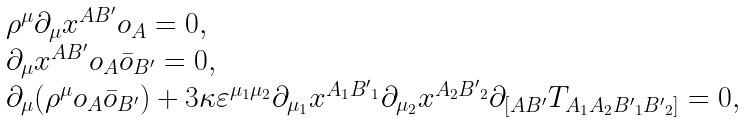Convert formula to latex. <formula><loc_0><loc_0><loc_500><loc_500>\begin{array} { l } \rho ^ { \mu } \partial _ { \mu } x ^ { A B ^ { \prime } } o _ { A } = 0 , \\ \partial _ { \mu } x ^ { A B ^ { \prime } } o _ { A } \bar { o } _ { B ^ { \prime } } = 0 , \\ \partial _ { \mu } ( \rho ^ { \mu } o _ { A } \bar { o } _ { B ^ { \prime } } ) + 3 \kappa \varepsilon ^ { \mu _ { 1 } \mu _ { 2 } } \partial _ { \mu _ { 1 } } x ^ { A _ { 1 } { B ^ { \prime } } _ { 1 } } \partial _ { \mu _ { 2 } } x ^ { A _ { 2 } { B ^ { \prime } } _ { 2 } } \partial _ { [ A B ^ { \prime } } T _ { A _ { 1 } A _ { 2 } { B ^ { \prime } } _ { 1 } { B ^ { \prime } } _ { 2 } ] } = 0 , \end{array}</formula> 